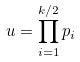Convert formula to latex. <formula><loc_0><loc_0><loc_500><loc_500>u = \prod _ { i = 1 } ^ { k / 2 } p _ { i }</formula> 